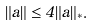<formula> <loc_0><loc_0><loc_500><loc_500>\| a \| \leq 4 \| a \| _ { * } .</formula> 